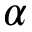Convert formula to latex. <formula><loc_0><loc_0><loc_500><loc_500>\alpha</formula> 